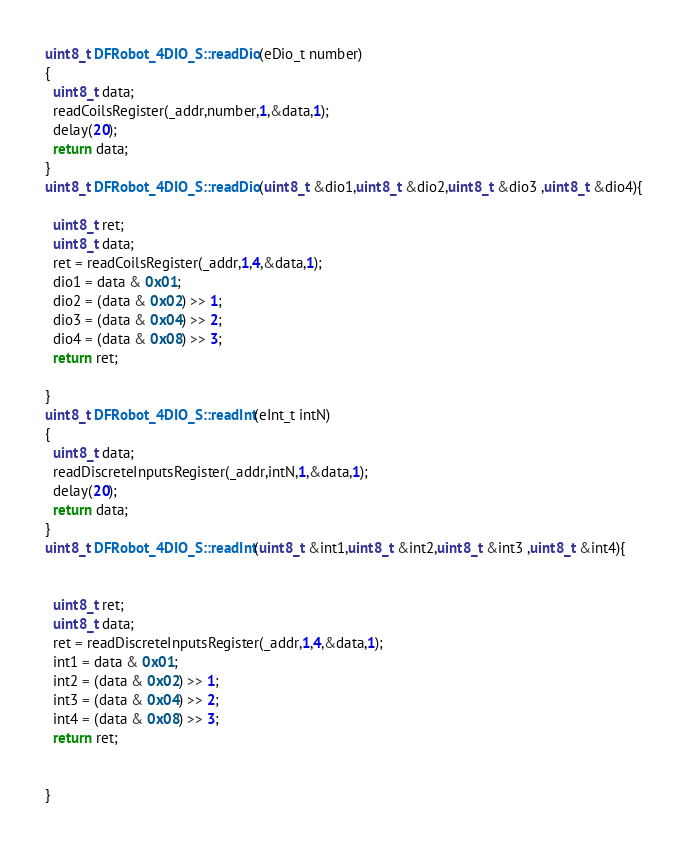<code> <loc_0><loc_0><loc_500><loc_500><_C++_>
uint8_t DFRobot_4DIO_S::readDio(eDio_t number)
{
  uint8_t data;
  readCoilsRegister(_addr,number,1,&data,1);
  delay(20);
  return data;
}
uint8_t DFRobot_4DIO_S::readDio(uint8_t &dio1,uint8_t &dio2,uint8_t &dio3 ,uint8_t &dio4){

  uint8_t ret;
  uint8_t data;
  ret = readCoilsRegister(_addr,1,4,&data,1);
  dio1 = data & 0x01;
  dio2 = (data & 0x02) >> 1;
  dio3 = (data & 0x04) >> 2;
  dio4 = (data & 0x08) >> 3;
  return ret;
  
}
uint8_t DFRobot_4DIO_S::readInt(eInt_t intN)
{
  uint8_t data;
  readDiscreteInputsRegister(_addr,intN,1,&data,1);
  delay(20);
  return data;
}
uint8_t DFRobot_4DIO_S::readInt(uint8_t &int1,uint8_t &int2,uint8_t &int3 ,uint8_t &int4){


  uint8_t ret;
  uint8_t data;
  ret = readDiscreteInputsRegister(_addr,1,4,&data,1);
  int1 = data & 0x01;
  int2 = (data & 0x02) >> 1;
  int3 = (data & 0x04) >> 2;
  int4 = (data & 0x08) >> 3;
  return ret;


}</code> 